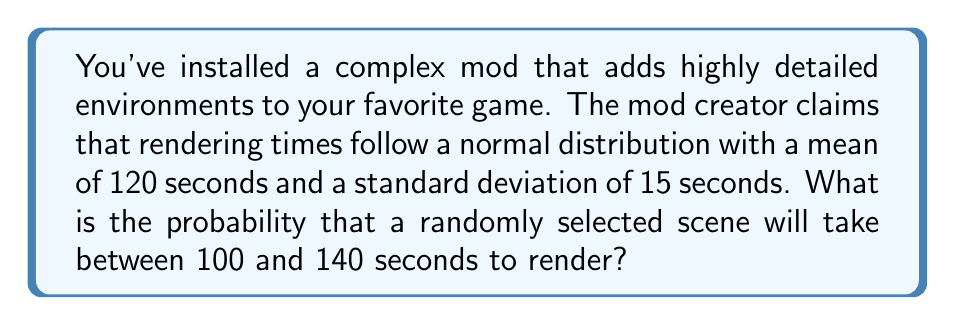Can you solve this math problem? To solve this problem, we'll use the properties of the normal distribution and the concept of z-scores.

1. Given information:
   - Mean (μ) = 120 seconds
   - Standard deviation (σ) = 15 seconds
   - We want to find P(100 < X < 140)

2. Convert the time range to z-scores:
   For 100 seconds: $z_1 = \frac{100 - 120}{15} = -1.33$
   For 140 seconds: $z_2 = \frac{140 - 120}{15} = 1.33$

3. The problem now becomes finding P(-1.33 < Z < 1.33)

4. Using the standard normal distribution table or a calculator:
   P(Z < 1.33) = 0.9082
   P(Z < -1.33) = 0.0918

5. The probability we're looking for is:
   P(-1.33 < Z < 1.33) = P(Z < 1.33) - P(Z < -1.33)
                       = 0.9082 - 0.0918
                       = 0.8164

6. Convert to percentage:
   0.8164 * 100% = 81.64%

Therefore, the probability that a randomly selected scene will take between 100 and 140 seconds to render is approximately 81.64%.
Answer: 81.64% 